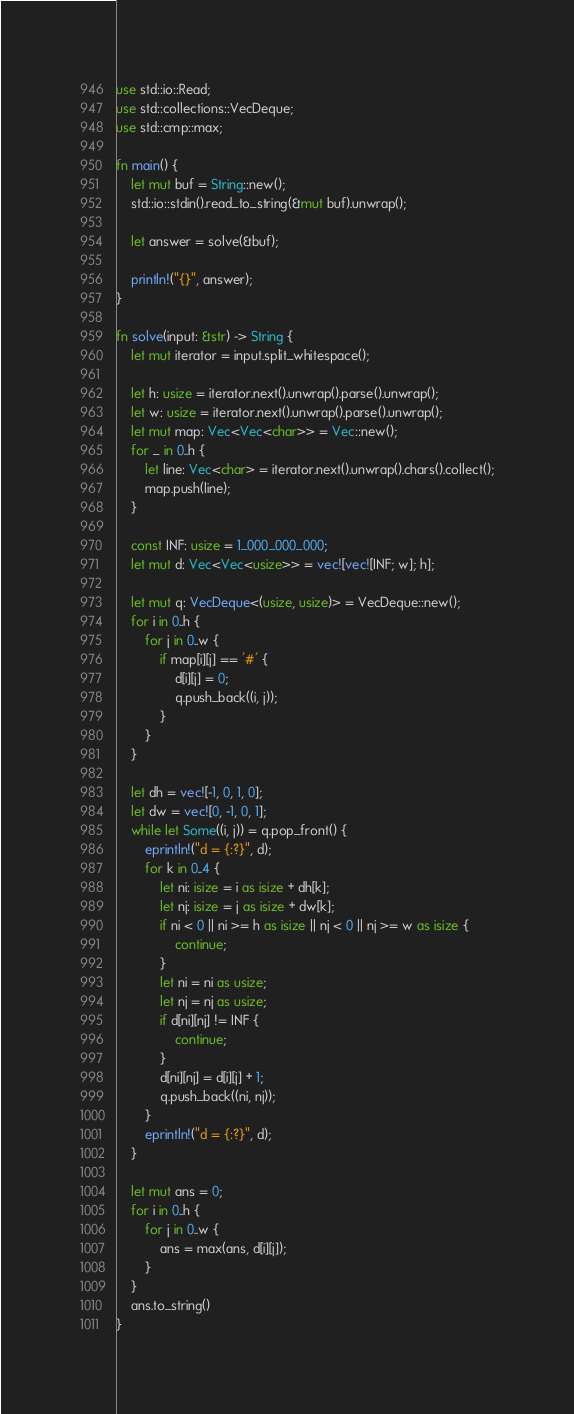Convert code to text. <code><loc_0><loc_0><loc_500><loc_500><_Rust_>use std::io::Read;
use std::collections::VecDeque;
use std::cmp::max;

fn main() {
    let mut buf = String::new();
    std::io::stdin().read_to_string(&mut buf).unwrap();

    let answer = solve(&buf);

    println!("{}", answer);
}

fn solve(input: &str) -> String {
    let mut iterator = input.split_whitespace();

    let h: usize = iterator.next().unwrap().parse().unwrap();
    let w: usize = iterator.next().unwrap().parse().unwrap();
    let mut map: Vec<Vec<char>> = Vec::new();
    for _ in 0..h {
        let line: Vec<char> = iterator.next().unwrap().chars().collect();
        map.push(line);
    }

    const INF: usize = 1_000_000_000;
    let mut d: Vec<Vec<usize>> = vec![vec![INF; w]; h];

    let mut q: VecDeque<(usize, usize)> = VecDeque::new();
    for i in 0..h {
        for j in 0..w {
            if map[i][j] == '#' {
                d[i][j] = 0;
                q.push_back((i, j));
            }
        }
    }

    let dh = vec![-1, 0, 1, 0];
    let dw = vec![0, -1, 0, 1];
    while let Some((i, j)) = q.pop_front() {
        eprintln!("d = {:?}", d);
        for k in 0..4 {
            let ni: isize = i as isize + dh[k];
            let nj: isize = j as isize + dw[k];
            if ni < 0 || ni >= h as isize || nj < 0 || nj >= w as isize {
                continue;
            }
            let ni = ni as usize;
            let nj = nj as usize;
            if d[ni][nj] != INF {
                continue;
            }
            d[ni][nj] = d[i][j] + 1;
            q.push_back((ni, nj));
        }
        eprintln!("d = {:?}", d);
    }

    let mut ans = 0;
    for i in 0..h {
        for j in 0..w {
            ans = max(ans, d[i][j]);
        }
    }
    ans.to_string()
}
</code> 